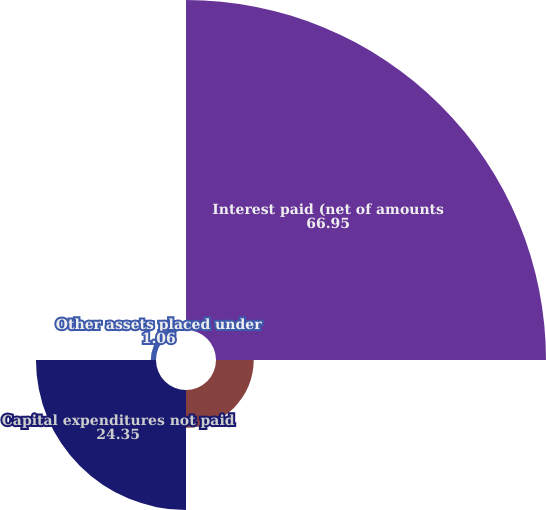Convert chart. <chart><loc_0><loc_0><loc_500><loc_500><pie_chart><fcel>Interest paid (net of amounts<fcel>Income taxes paid<fcel>Capital expenditures not paid<fcel>Other assets placed under<nl><fcel>66.95%<fcel>7.65%<fcel>24.35%<fcel>1.06%<nl></chart> 